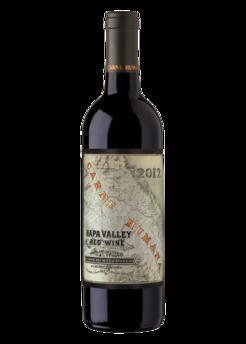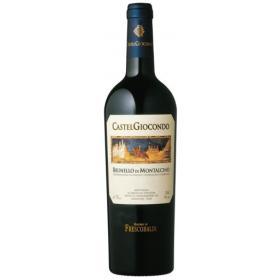The first image is the image on the left, the second image is the image on the right. For the images shown, is this caption "One image shows a bottle of wine with a black background." true? Answer yes or no. Yes. 